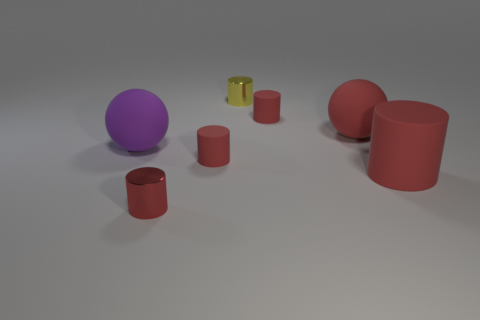How many big things are left of the large red matte cylinder? There are two large objects to the left of the large red matte cylinder: a purple sphere and another red cylinder. These objects are positioned horizontally relative to the cylinder. 